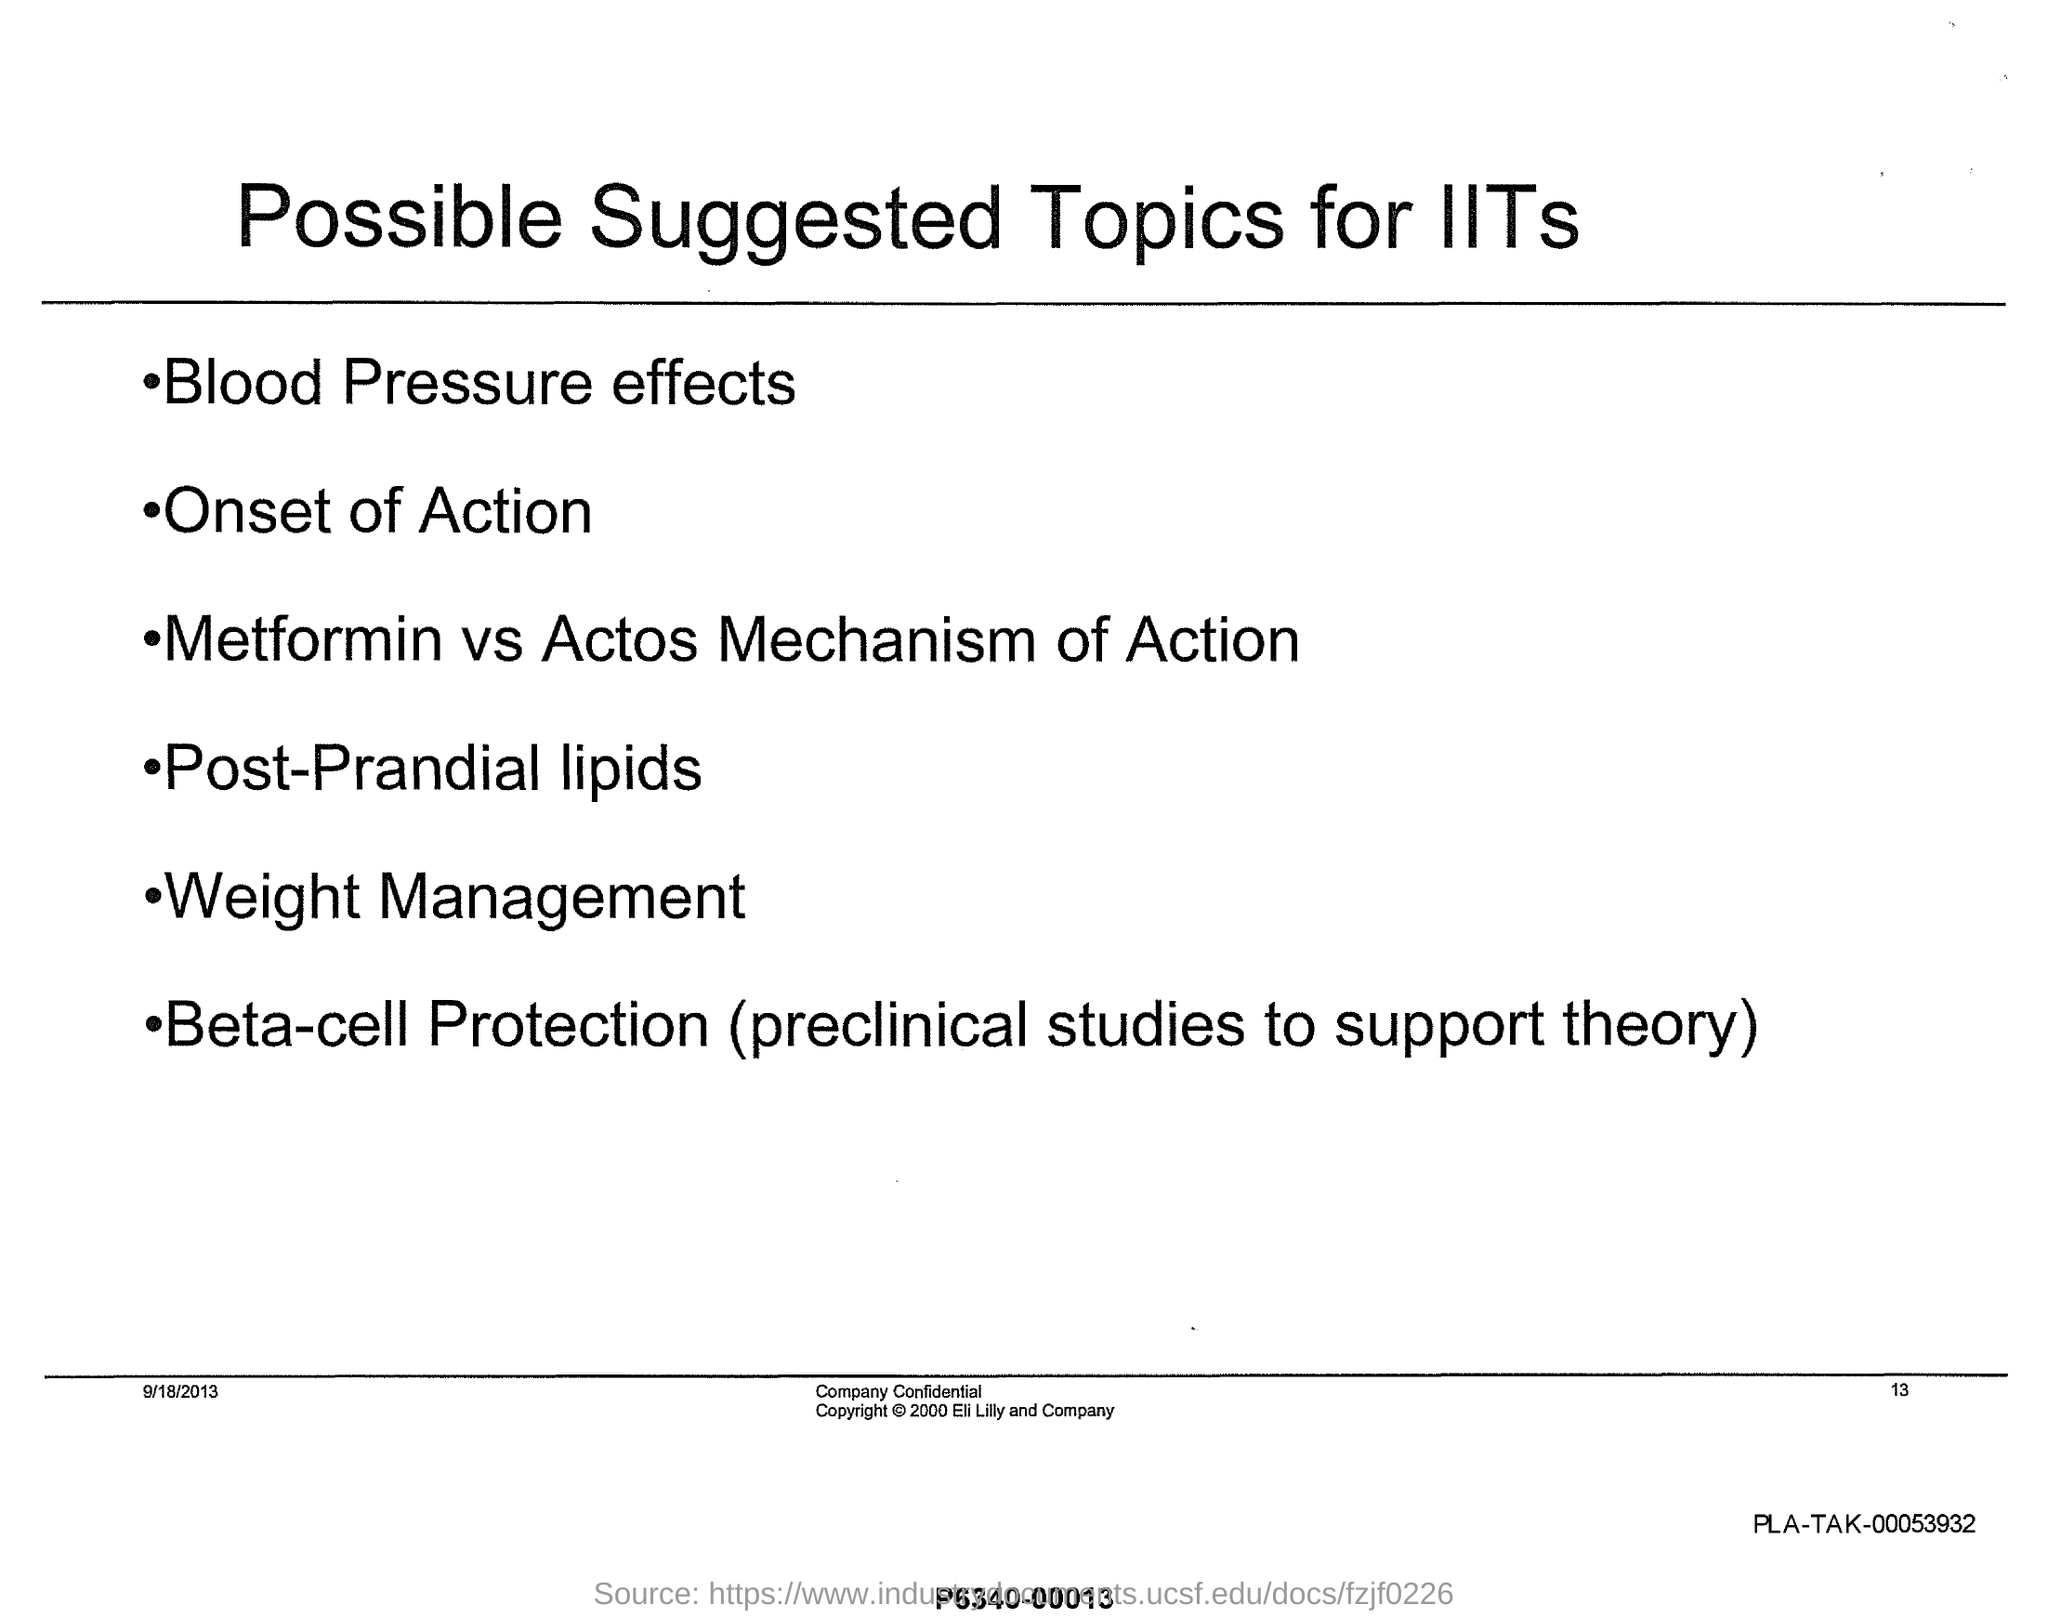What is the title of this document?
Offer a terse response. Possible Suggested Topics for IITs. What is listed first in the possible suggested topics for IITs?
Provide a short and direct response. Blood pressure effects. What is listed second in the possible suggested topics for IITs?
Keep it short and to the point. Onset of Action. 